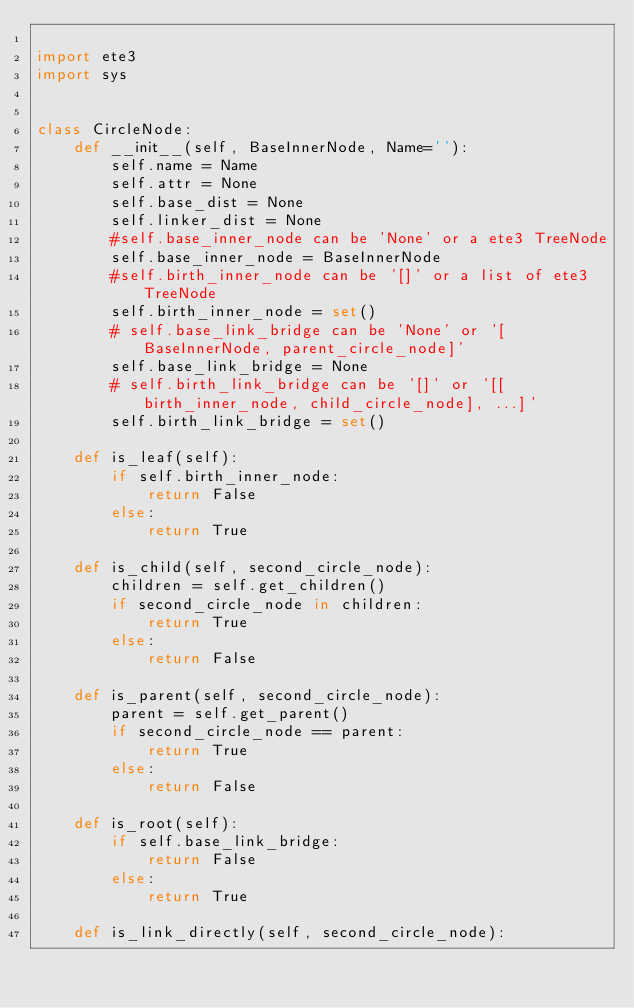Convert code to text. <code><loc_0><loc_0><loc_500><loc_500><_Python_>
import ete3
import sys


class CircleNode:
    def __init__(self, BaseInnerNode, Name=''):
        self.name = Name
        self.attr = None
        self.base_dist = None
        self.linker_dist = None
        #self.base_inner_node can be 'None' or a ete3 TreeNode
        self.base_inner_node = BaseInnerNode
        #self.birth_inner_node can be '[]' or a list of ete3 TreeNode
        self.birth_inner_node = set()
        # self.base_link_bridge can be 'None' or '[BaseInnerNode, parent_circle_node]'
        self.base_link_bridge = None
        # self.birth_link_bridge can be '[]' or '[[birth_inner_node, child_circle_node], ...]'
        self.birth_link_bridge = set()

    def is_leaf(self):
        if self.birth_inner_node:
            return False
        else:
            return True

    def is_child(self, second_circle_node):
        children = self.get_children()
        if second_circle_node in children:
            return True
        else:
            return False

    def is_parent(self, second_circle_node):
        parent = self.get_parent()
        if second_circle_node == parent:
            return True
        else:
            return False

    def is_root(self):
        if self.base_link_bridge:
            return False
        else:
            return True

    def is_link_directly(self, second_circle_node):</code> 